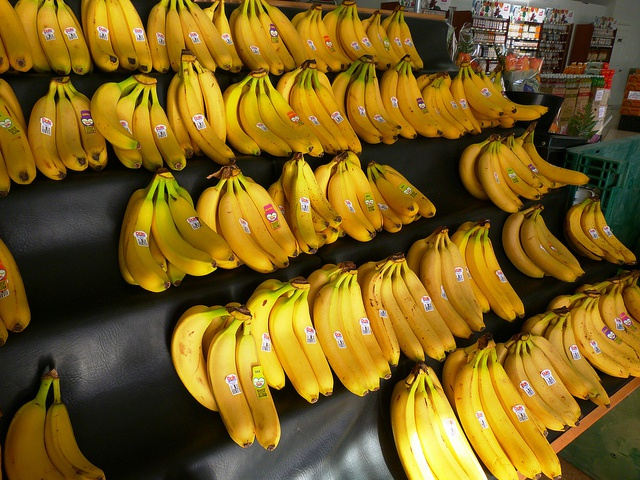Describe the objects in this image and their specific colors. I can see banana in orange, olive, and black tones, banana in orange, olive, and maroon tones, banana in orange and olive tones, banana in orange, yellow, gold, ivory, and khaki tones, and banana in orange, olive, gold, and black tones in this image. 